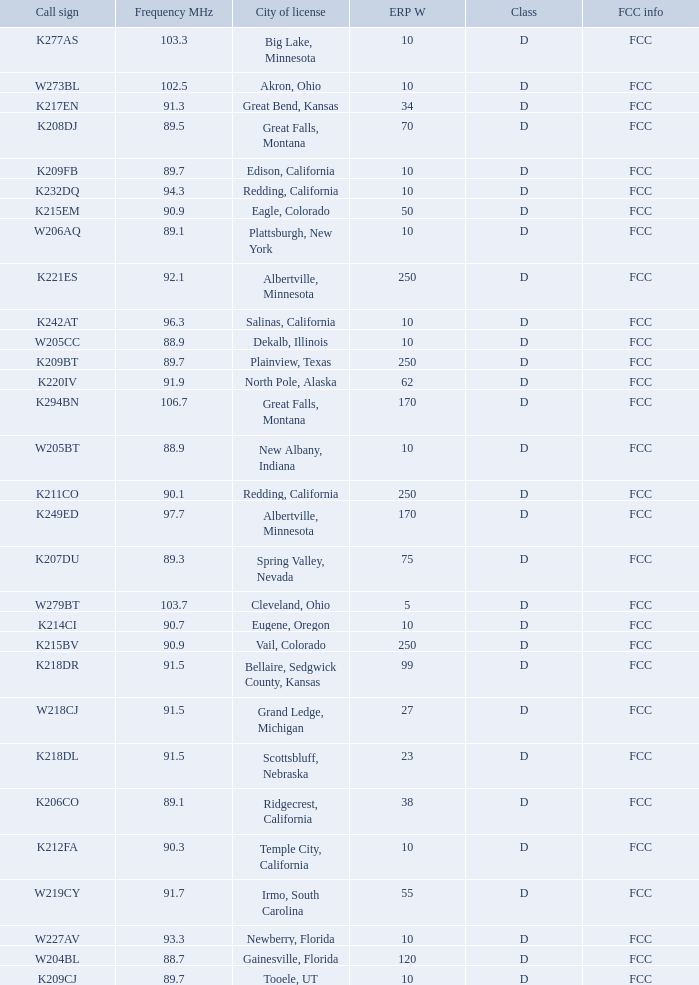What is the class of the translator with 10 ERP W and a call sign of w273bl? D. 